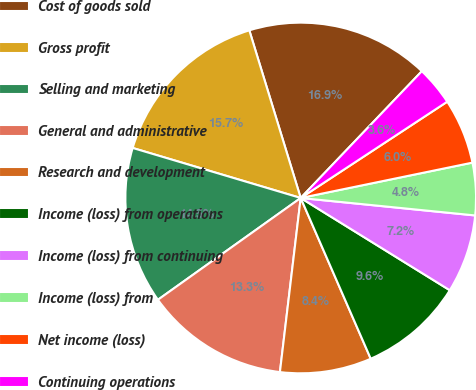Convert chart. <chart><loc_0><loc_0><loc_500><loc_500><pie_chart><fcel>Cost of goods sold<fcel>Gross profit<fcel>Selling and marketing<fcel>General and administrative<fcel>Research and development<fcel>Income (loss) from operations<fcel>Income (loss) from continuing<fcel>Income (loss) from<fcel>Net income (loss)<fcel>Continuing operations<nl><fcel>16.87%<fcel>15.66%<fcel>14.46%<fcel>13.25%<fcel>8.43%<fcel>9.64%<fcel>7.23%<fcel>4.82%<fcel>6.02%<fcel>3.61%<nl></chart> 